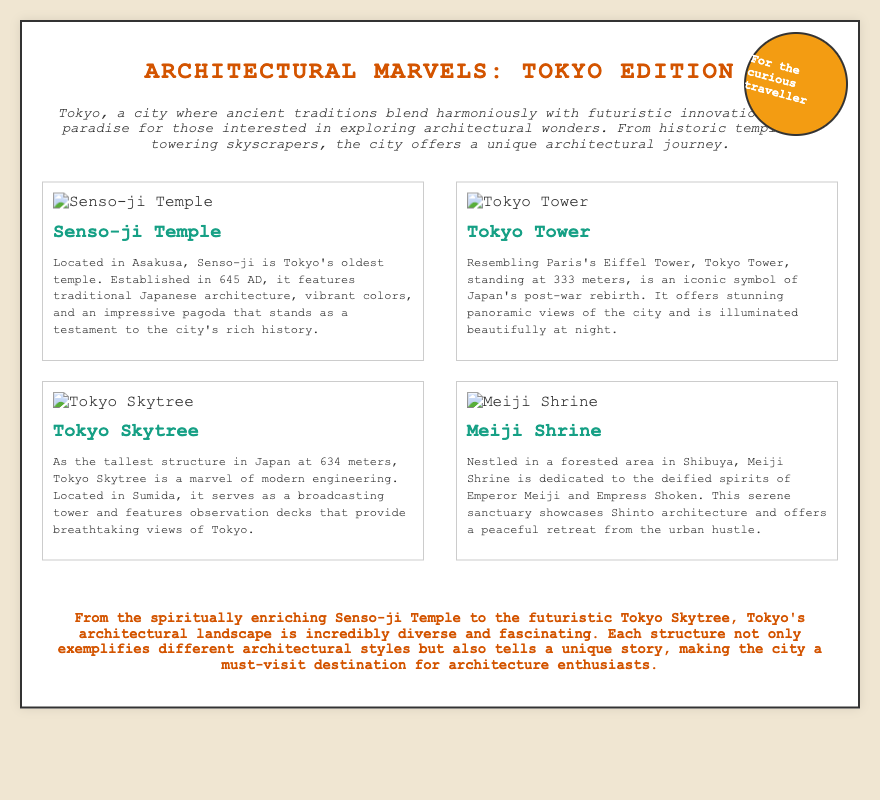What is the title of the Playbill? The title of the Playbill is prominently displayed and describes the theme of the document.
Answer: Architectural Marvels: Tokyo Edition What year was Senso-ji Temple established? The document includes the founding year of Senso-ji Temple, specifying its historic significance.
Answer: 645 AD What is the height of Tokyo Skytree? The height of Tokyo Skytree is mentioned in the description of the structure.
Answer: 634 meters Where is Meiji Shrine located? The document specifies the area where Meiji Shrine can be found in Tokyo.
Answer: Shibuya Which structure resembles Paris's Eiffel Tower? This question seeks to identify a specific building that has a notable comparison to another famous landmark.
Answer: Tokyo Tower How many highlights are featured in the Playbill? Counting the various highlights section reveals the number of architectural features presented.
Answer: Four What is the architectural style of Meiji Shrine described as? This question aims to extract the style mentioned in relation to Meiji Shrine from the document.
Answer: Shinto architecture What color is the stamp on the Playbill? The document describes the appearance of the stamp, including its colors used in the design.
Answer: Orange 